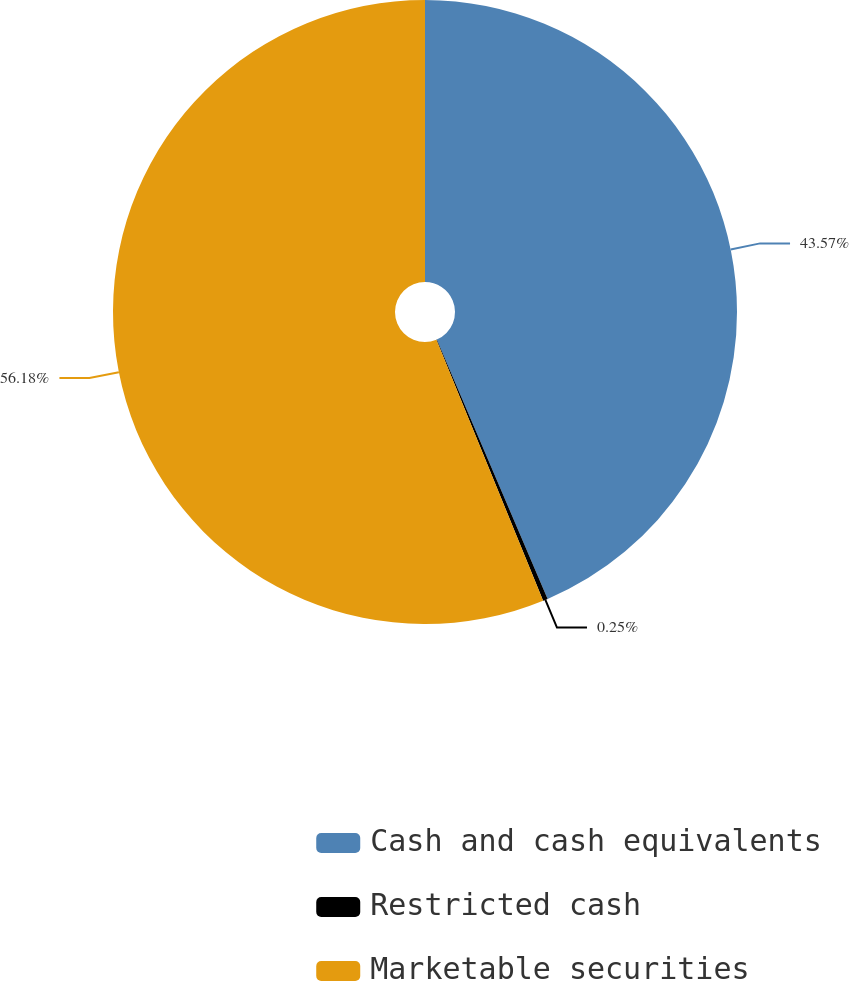Convert chart. <chart><loc_0><loc_0><loc_500><loc_500><pie_chart><fcel>Cash and cash equivalents<fcel>Restricted cash<fcel>Marketable securities<nl><fcel>43.57%<fcel>0.25%<fcel>56.18%<nl></chart> 